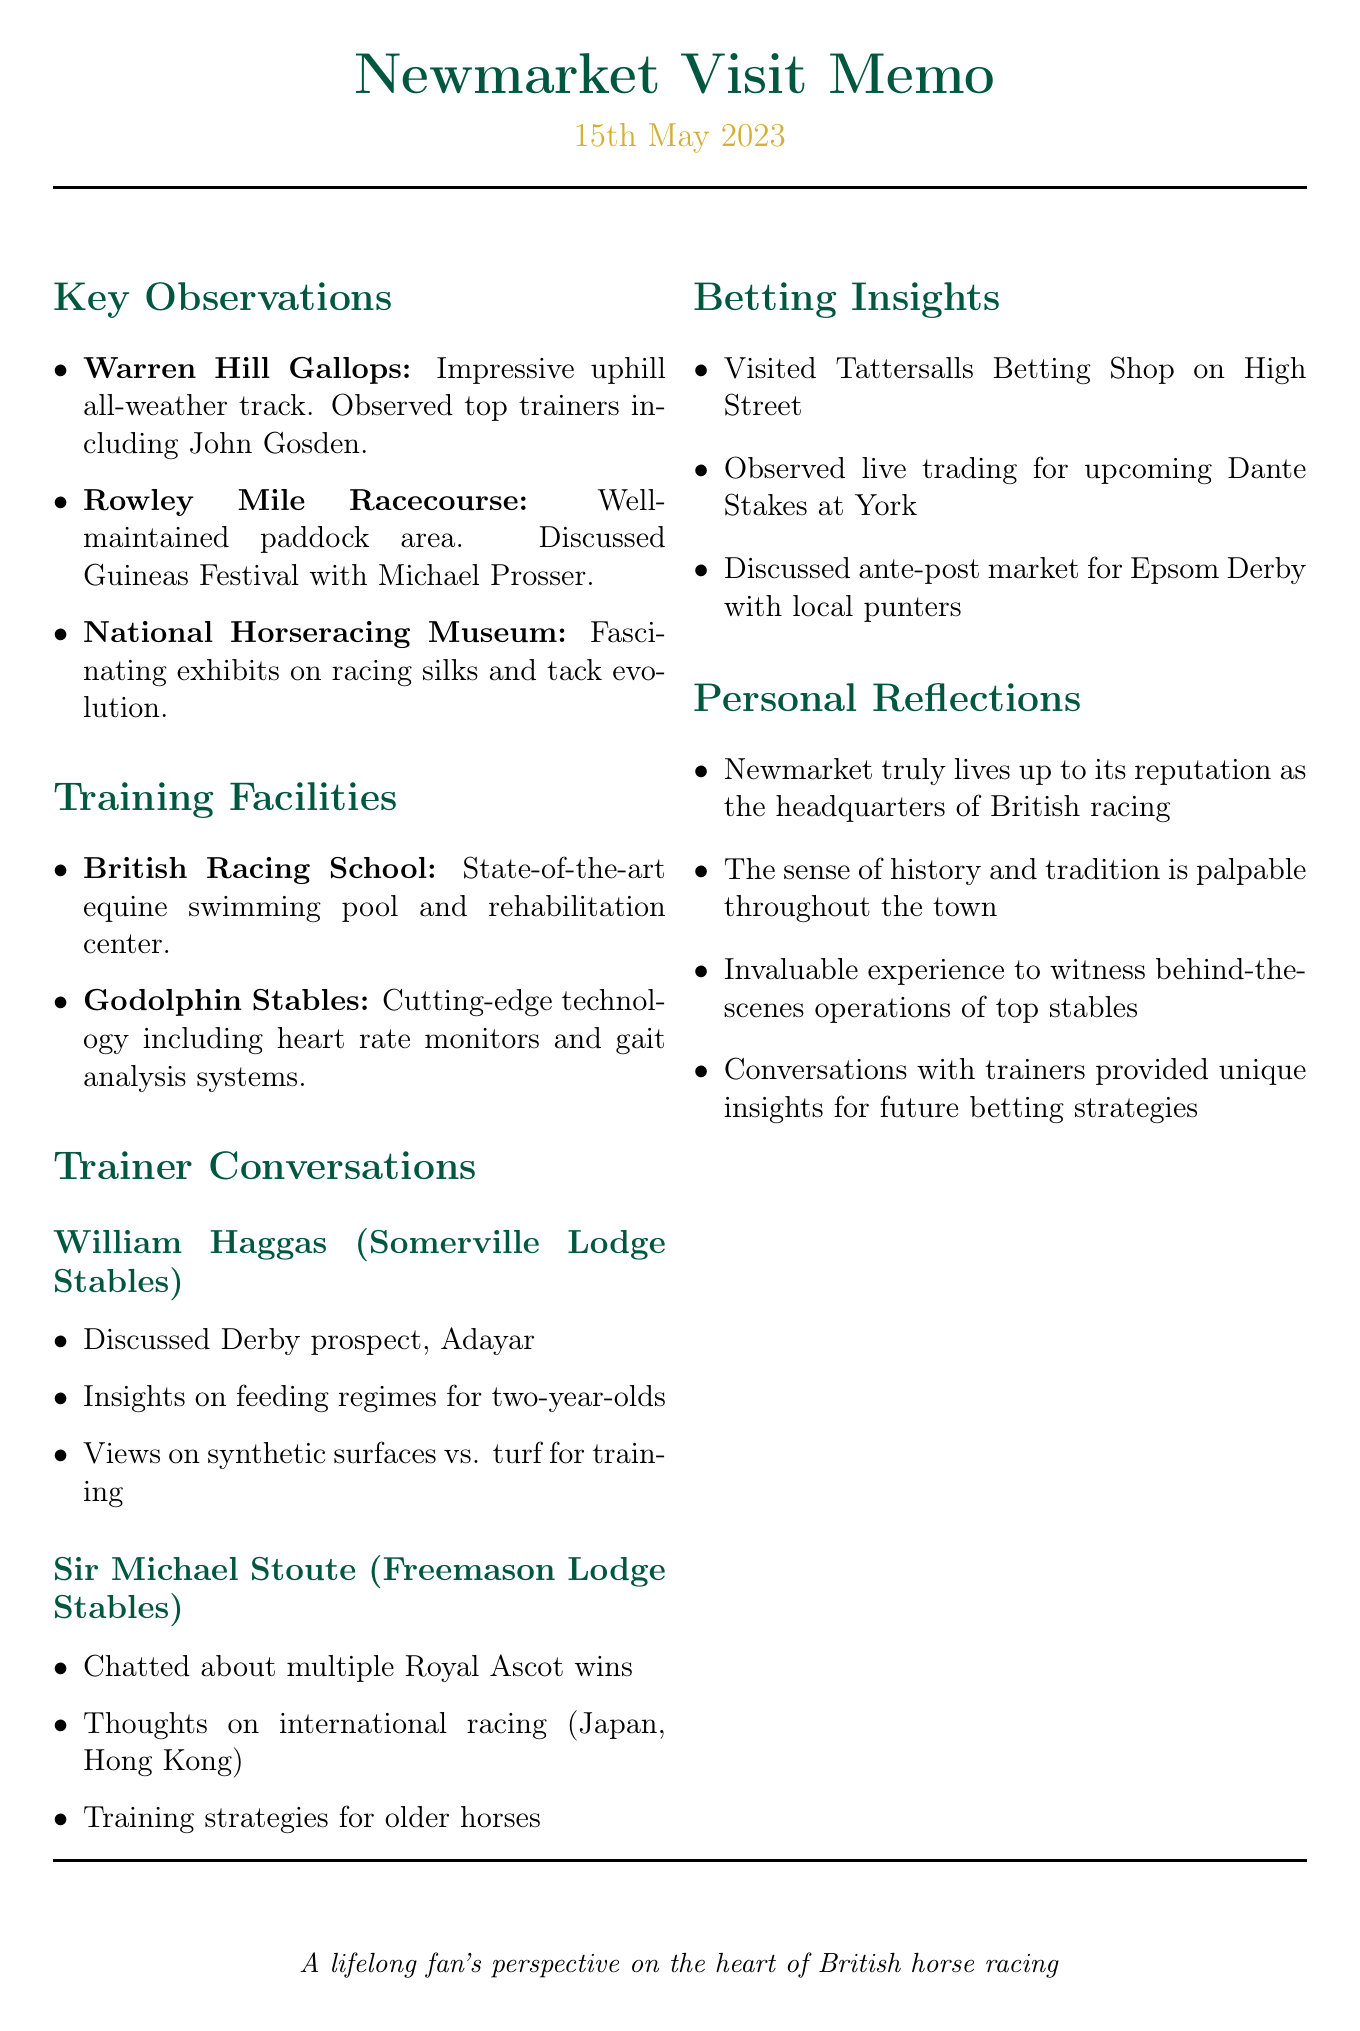What date was the visit to Newmarket? The visit date is explicitly mentioned at the beginning of the document as "15th May 2023."
Answer: 15th May 2023 Which area was known for its uphill all-weather track? The document specifies that the "Warren Hill Gallops" has an impressive uphill all-weather track where morning workouts were observed.
Answer: Warren Hill Gallops Who oversees the string of horses at Warren Hill Gallops? The visit notes mention that several top trainers, notably John Gosden, were overseeing their strings at the gallops.
Answer: John Gosden What technology is used at Godolphin Stables? The training facilities section indicates that Godolphin Stables employs "heart rate monitors and gait analysis systems."
Answer: Heart rate monitors and gait analysis systems Who did the author speak with about the Epsom Derby? The document notes that the author discussed the ante-post market for the Epsom Derby with local punters during their visit to the Tattersalls Betting Shop.
Answer: Local punters What significant insight did conversations with trainers provide? In the personal reflections, it is stated that conversations with trainers offered "unique insights for future betting strategies."
Answer: Unique insights for future betting strategies What are the two racing locations mentioned in the trainer conversations? The trainers William Haggas and Sir Michael Stoute are associated with "Somerville Lodge Stables" and "Freemason Lodge Stables," respectively.
Answer: Somerville Lodge Stables and Freemason Lodge Stables How much time was spent exploring the National Horseracing Museum? The notes indicate that the author spent an hour exploring the exhibits at the museum.
Answer: An hour 